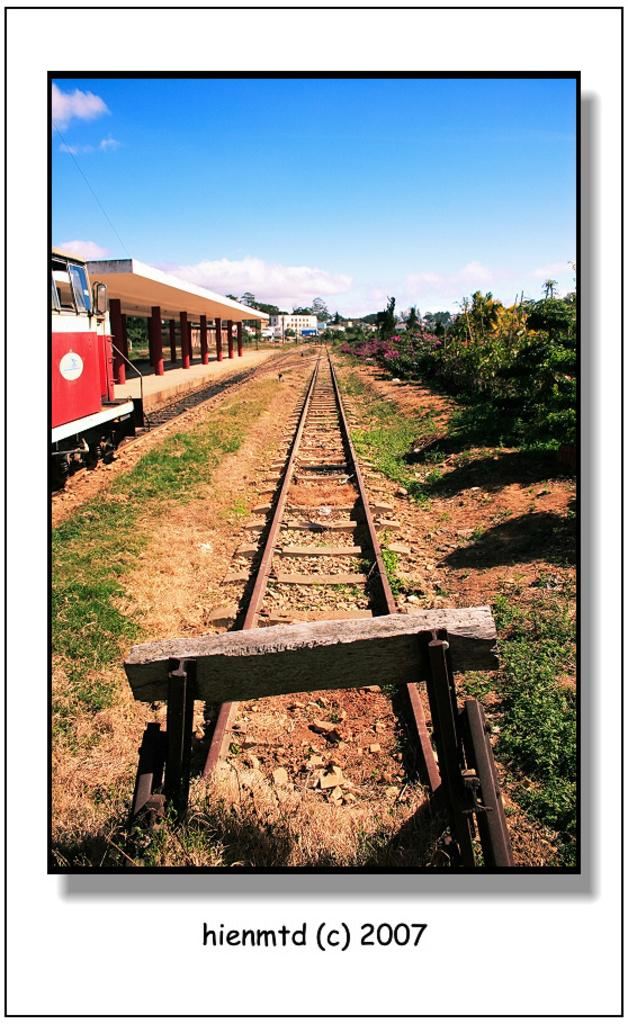Provide a one-sentence caption for the provided image. A long, narrow train track photographed in 2007. 